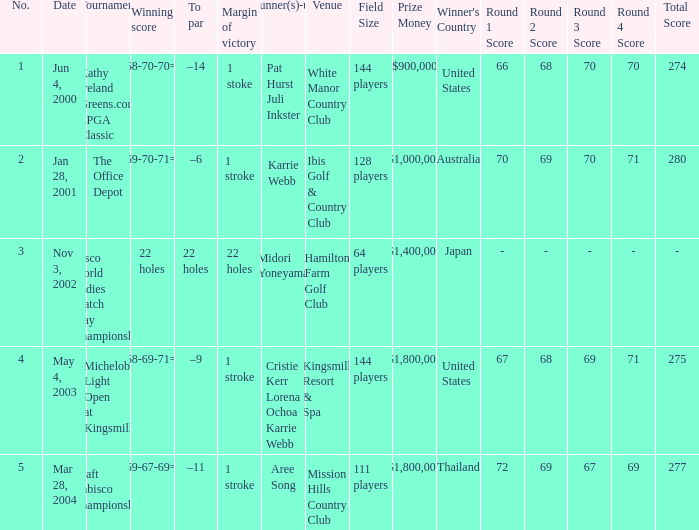Could you parse the entire table as a dict? {'header': ['No.', 'Date', 'Tournament', 'Winning score', 'To par', 'Margin of victory', 'Runner(s)-up', 'Venue', 'Field Size', 'Prize Money', "Winner's Country", 'Round 1 Score', 'Round 2 Score', 'Round 3 Score', 'Round 4 Score', 'Total Score'], 'rows': [['1', 'Jun 4, 2000', 'Kathy Ireland Greens.com LPGA Classic', '66-68-70-70=274', '–14', '1 stoke', 'Pat Hurst Juli Inkster', 'White Manor Country Club', '144 players', '$900,000', 'United States', '66', '68', '70', '70', '274'], ['2', 'Jan 28, 2001', 'The Office Depot', '70-69-70-71=280', '–6', '1 stroke', 'Karrie Webb', 'Ibis Golf & Country Club', '128 players', '$1,000,000', 'Australia', '70', '69', '70', '71', '280'], ['3', 'Nov 3, 2002', 'Cisco World Ladies Match Play Championship', '22 holes', '22 holes', '22 holes', 'Midori Yoneyama', 'Hamilton Farm Golf Club', '64 players', '$1,400,000', 'Japan', '-', '-', '-', '-', '-'], ['4', 'May 4, 2003', 'Michelob Light Open at Kingsmill', '67-68-69-71=275', '–9', '1 stroke', 'Cristie Kerr Lorena Ochoa Karrie Webb', 'Kingsmill Resort & Spa', '144 players', '$1,800,000', 'United States', '67', '68', '69', '71', '275'], ['5', 'Mar 28, 2004', 'Kraft Nabisco Championship', '72-69-67-69=277', '–11', '1 stroke', 'Aree Song', 'Mission Hills Country Club', '111 players', '$1,800,000', 'Thailand', '72', '69', '67', '69', '277']]} Where was the tournament dated nov 3, 2002? Cisco World Ladies Match Play Championship. 